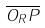Convert formula to latex. <formula><loc_0><loc_0><loc_500><loc_500>\overline { O _ { R } P }</formula> 